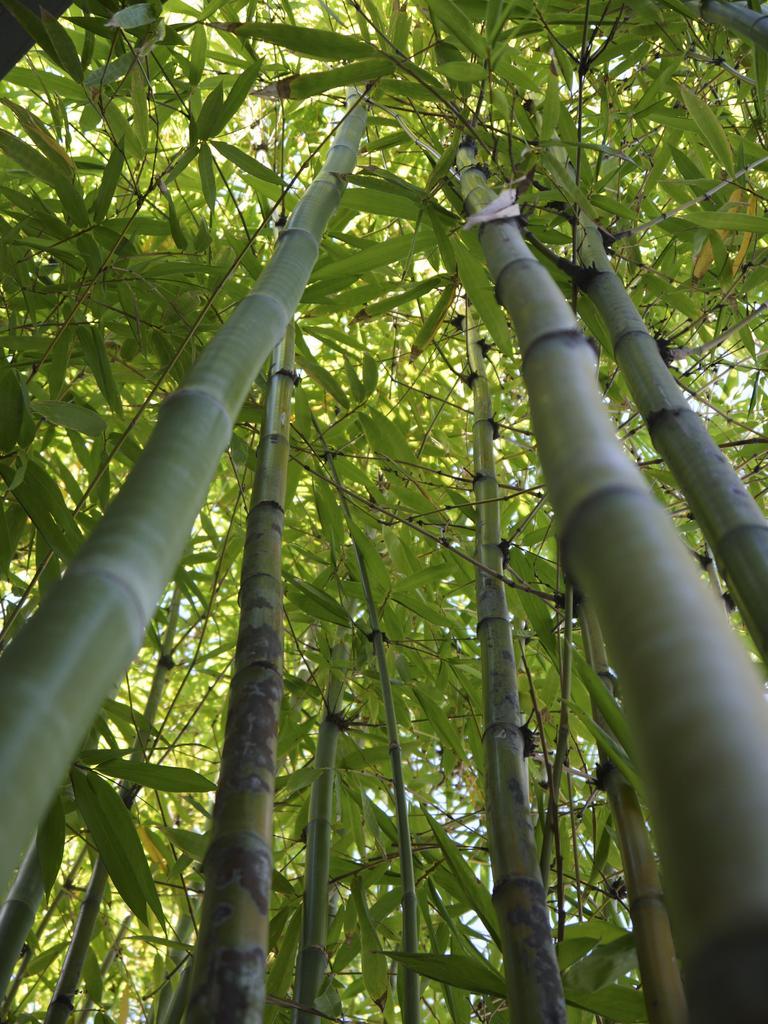In one or two sentences, can you explain what this image depicts? In this picture I can see that there are some bamboo trees and there are some leaves on the trees. 